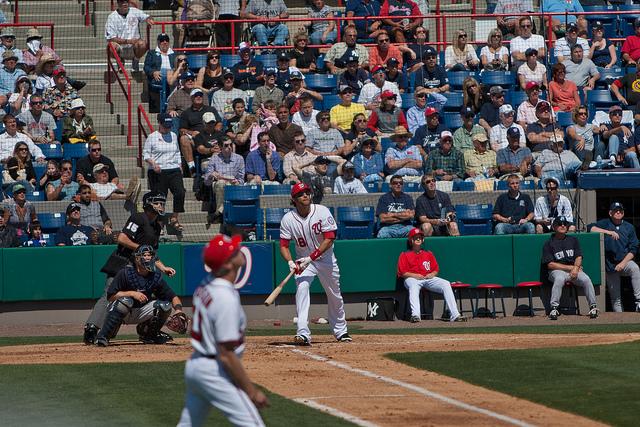What is the number of the person at bat?
Quick response, please. 8. Will the batter hit the ball?
Answer briefly. Yes. What is the player hoping to do with the bat?
Short answer required. Hit ball. Are the seats mostly empty or full?
Short answer required. Full. Is it snowing?
Keep it brief. No. What sport is being played?
Concise answer only. Baseball. Are there female spectators in the stadium?
Write a very short answer. Yes. Where are the audience?
Keep it brief. Stands. How many people are pictured in the photo?
Give a very brief answer. Many. How many fans are in the field?
Keep it brief. 50. What color is the batter's helmet?
Answer briefly. Red. What is the batter standing on?
Give a very brief answer. Plate. How many players in blue and white?
Write a very short answer. 2. 